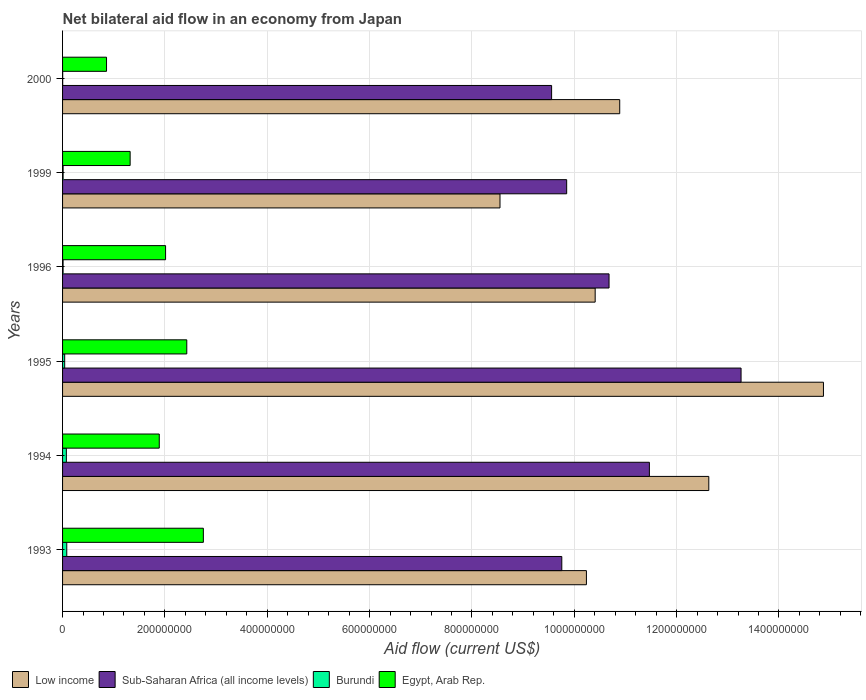How many different coloured bars are there?
Provide a short and direct response. 4. Are the number of bars on each tick of the Y-axis equal?
Your response must be concise. Yes. How many bars are there on the 6th tick from the top?
Offer a very short reply. 4. What is the label of the 6th group of bars from the top?
Provide a succinct answer. 1993. What is the net bilateral aid flow in Egypt, Arab Rep. in 1995?
Provide a succinct answer. 2.43e+08. Across all years, what is the maximum net bilateral aid flow in Burundi?
Your answer should be very brief. 8.21e+06. Across all years, what is the minimum net bilateral aid flow in Low income?
Offer a terse response. 8.55e+08. In which year was the net bilateral aid flow in Sub-Saharan Africa (all income levels) maximum?
Offer a terse response. 1995. What is the total net bilateral aid flow in Egypt, Arab Rep. in the graph?
Make the answer very short. 1.13e+09. What is the difference between the net bilateral aid flow in Burundi in 1994 and that in 2000?
Your answer should be very brief. 7.18e+06. What is the difference between the net bilateral aid flow in Burundi in 1995 and the net bilateral aid flow in Egypt, Arab Rep. in 1999?
Offer a terse response. -1.28e+08. What is the average net bilateral aid flow in Egypt, Arab Rep. per year?
Your answer should be very brief. 1.88e+08. In the year 1996, what is the difference between the net bilateral aid flow in Sub-Saharan Africa (all income levels) and net bilateral aid flow in Low income?
Offer a terse response. 2.71e+07. What is the ratio of the net bilateral aid flow in Egypt, Arab Rep. in 1993 to that in 1999?
Give a very brief answer. 2.08. Is the net bilateral aid flow in Egypt, Arab Rep. in 1994 less than that in 1995?
Offer a terse response. Yes. What is the difference between the highest and the second highest net bilateral aid flow in Burundi?
Keep it short and to the point. 7.90e+05. What is the difference between the highest and the lowest net bilateral aid flow in Sub-Saharan Africa (all income levels)?
Offer a very short reply. 3.70e+08. In how many years, is the net bilateral aid flow in Egypt, Arab Rep. greater than the average net bilateral aid flow in Egypt, Arab Rep. taken over all years?
Give a very brief answer. 4. What does the 3rd bar from the top in 1994 represents?
Your answer should be compact. Sub-Saharan Africa (all income levels). What does the 3rd bar from the bottom in 1993 represents?
Keep it short and to the point. Burundi. How many bars are there?
Your response must be concise. 24. How many years are there in the graph?
Your response must be concise. 6. Does the graph contain any zero values?
Provide a short and direct response. No. Where does the legend appear in the graph?
Give a very brief answer. Bottom left. How many legend labels are there?
Provide a short and direct response. 4. What is the title of the graph?
Give a very brief answer. Net bilateral aid flow in an economy from Japan. Does "Zimbabwe" appear as one of the legend labels in the graph?
Make the answer very short. No. What is the label or title of the Y-axis?
Provide a succinct answer. Years. What is the Aid flow (current US$) in Low income in 1993?
Keep it short and to the point. 1.02e+09. What is the Aid flow (current US$) of Sub-Saharan Africa (all income levels) in 1993?
Keep it short and to the point. 9.76e+08. What is the Aid flow (current US$) in Burundi in 1993?
Offer a very short reply. 8.21e+06. What is the Aid flow (current US$) of Egypt, Arab Rep. in 1993?
Ensure brevity in your answer.  2.75e+08. What is the Aid flow (current US$) of Low income in 1994?
Give a very brief answer. 1.26e+09. What is the Aid flow (current US$) in Sub-Saharan Africa (all income levels) in 1994?
Offer a terse response. 1.15e+09. What is the Aid flow (current US$) of Burundi in 1994?
Your answer should be very brief. 7.42e+06. What is the Aid flow (current US$) in Egypt, Arab Rep. in 1994?
Your response must be concise. 1.89e+08. What is the Aid flow (current US$) in Low income in 1995?
Your response must be concise. 1.49e+09. What is the Aid flow (current US$) in Sub-Saharan Africa (all income levels) in 1995?
Your answer should be compact. 1.33e+09. What is the Aid flow (current US$) of Burundi in 1995?
Provide a succinct answer. 4.14e+06. What is the Aid flow (current US$) in Egypt, Arab Rep. in 1995?
Your answer should be very brief. 2.43e+08. What is the Aid flow (current US$) of Low income in 1996?
Offer a terse response. 1.04e+09. What is the Aid flow (current US$) of Sub-Saharan Africa (all income levels) in 1996?
Give a very brief answer. 1.07e+09. What is the Aid flow (current US$) in Burundi in 1996?
Offer a terse response. 1.01e+06. What is the Aid flow (current US$) in Egypt, Arab Rep. in 1996?
Keep it short and to the point. 2.01e+08. What is the Aid flow (current US$) of Low income in 1999?
Offer a very short reply. 8.55e+08. What is the Aid flow (current US$) in Sub-Saharan Africa (all income levels) in 1999?
Give a very brief answer. 9.85e+08. What is the Aid flow (current US$) of Burundi in 1999?
Your response must be concise. 1.06e+06. What is the Aid flow (current US$) in Egypt, Arab Rep. in 1999?
Your answer should be compact. 1.32e+08. What is the Aid flow (current US$) of Low income in 2000?
Make the answer very short. 1.09e+09. What is the Aid flow (current US$) in Sub-Saharan Africa (all income levels) in 2000?
Offer a terse response. 9.56e+08. What is the Aid flow (current US$) of Egypt, Arab Rep. in 2000?
Make the answer very short. 8.59e+07. Across all years, what is the maximum Aid flow (current US$) of Low income?
Give a very brief answer. 1.49e+09. Across all years, what is the maximum Aid flow (current US$) of Sub-Saharan Africa (all income levels)?
Make the answer very short. 1.33e+09. Across all years, what is the maximum Aid flow (current US$) of Burundi?
Offer a very short reply. 8.21e+06. Across all years, what is the maximum Aid flow (current US$) of Egypt, Arab Rep.?
Keep it short and to the point. 2.75e+08. Across all years, what is the minimum Aid flow (current US$) of Low income?
Your answer should be very brief. 8.55e+08. Across all years, what is the minimum Aid flow (current US$) in Sub-Saharan Africa (all income levels)?
Offer a very short reply. 9.56e+08. Across all years, what is the minimum Aid flow (current US$) in Burundi?
Your answer should be very brief. 2.40e+05. Across all years, what is the minimum Aid flow (current US$) of Egypt, Arab Rep.?
Make the answer very short. 8.59e+07. What is the total Aid flow (current US$) in Low income in the graph?
Your answer should be very brief. 6.76e+09. What is the total Aid flow (current US$) in Sub-Saharan Africa (all income levels) in the graph?
Offer a terse response. 6.46e+09. What is the total Aid flow (current US$) in Burundi in the graph?
Make the answer very short. 2.21e+07. What is the total Aid flow (current US$) of Egypt, Arab Rep. in the graph?
Offer a terse response. 1.13e+09. What is the difference between the Aid flow (current US$) in Low income in 1993 and that in 1994?
Ensure brevity in your answer.  -2.39e+08. What is the difference between the Aid flow (current US$) in Sub-Saharan Africa (all income levels) in 1993 and that in 1994?
Give a very brief answer. -1.71e+08. What is the difference between the Aid flow (current US$) in Burundi in 1993 and that in 1994?
Make the answer very short. 7.90e+05. What is the difference between the Aid flow (current US$) of Egypt, Arab Rep. in 1993 and that in 1994?
Give a very brief answer. 8.62e+07. What is the difference between the Aid flow (current US$) in Low income in 1993 and that in 1995?
Ensure brevity in your answer.  -4.63e+08. What is the difference between the Aid flow (current US$) of Sub-Saharan Africa (all income levels) in 1993 and that in 1995?
Offer a terse response. -3.50e+08. What is the difference between the Aid flow (current US$) in Burundi in 1993 and that in 1995?
Offer a very short reply. 4.07e+06. What is the difference between the Aid flow (current US$) of Egypt, Arab Rep. in 1993 and that in 1995?
Offer a very short reply. 3.24e+07. What is the difference between the Aid flow (current US$) of Low income in 1993 and that in 1996?
Make the answer very short. -1.71e+07. What is the difference between the Aid flow (current US$) in Sub-Saharan Africa (all income levels) in 1993 and that in 1996?
Offer a terse response. -9.23e+07. What is the difference between the Aid flow (current US$) of Burundi in 1993 and that in 1996?
Give a very brief answer. 7.20e+06. What is the difference between the Aid flow (current US$) of Egypt, Arab Rep. in 1993 and that in 1996?
Offer a very short reply. 7.38e+07. What is the difference between the Aid flow (current US$) in Low income in 1993 and that in 1999?
Your response must be concise. 1.69e+08. What is the difference between the Aid flow (current US$) in Sub-Saharan Africa (all income levels) in 1993 and that in 1999?
Your answer should be compact. -9.54e+06. What is the difference between the Aid flow (current US$) in Burundi in 1993 and that in 1999?
Give a very brief answer. 7.15e+06. What is the difference between the Aid flow (current US$) in Egypt, Arab Rep. in 1993 and that in 1999?
Provide a succinct answer. 1.43e+08. What is the difference between the Aid flow (current US$) in Low income in 1993 and that in 2000?
Your response must be concise. -6.51e+07. What is the difference between the Aid flow (current US$) in Sub-Saharan Africa (all income levels) in 1993 and that in 2000?
Your response must be concise. 1.99e+07. What is the difference between the Aid flow (current US$) of Burundi in 1993 and that in 2000?
Your answer should be very brief. 7.97e+06. What is the difference between the Aid flow (current US$) of Egypt, Arab Rep. in 1993 and that in 2000?
Offer a very short reply. 1.89e+08. What is the difference between the Aid flow (current US$) in Low income in 1994 and that in 1995?
Give a very brief answer. -2.24e+08. What is the difference between the Aid flow (current US$) of Sub-Saharan Africa (all income levels) in 1994 and that in 1995?
Your answer should be very brief. -1.79e+08. What is the difference between the Aid flow (current US$) of Burundi in 1994 and that in 1995?
Offer a very short reply. 3.28e+06. What is the difference between the Aid flow (current US$) in Egypt, Arab Rep. in 1994 and that in 1995?
Provide a succinct answer. -5.38e+07. What is the difference between the Aid flow (current US$) in Low income in 1994 and that in 1996?
Give a very brief answer. 2.22e+08. What is the difference between the Aid flow (current US$) of Sub-Saharan Africa (all income levels) in 1994 and that in 1996?
Provide a short and direct response. 7.88e+07. What is the difference between the Aid flow (current US$) of Burundi in 1994 and that in 1996?
Provide a short and direct response. 6.41e+06. What is the difference between the Aid flow (current US$) in Egypt, Arab Rep. in 1994 and that in 1996?
Offer a terse response. -1.23e+07. What is the difference between the Aid flow (current US$) in Low income in 1994 and that in 1999?
Your answer should be very brief. 4.08e+08. What is the difference between the Aid flow (current US$) in Sub-Saharan Africa (all income levels) in 1994 and that in 1999?
Ensure brevity in your answer.  1.62e+08. What is the difference between the Aid flow (current US$) in Burundi in 1994 and that in 1999?
Provide a short and direct response. 6.36e+06. What is the difference between the Aid flow (current US$) of Egypt, Arab Rep. in 1994 and that in 1999?
Provide a short and direct response. 5.69e+07. What is the difference between the Aid flow (current US$) of Low income in 1994 and that in 2000?
Ensure brevity in your answer.  1.74e+08. What is the difference between the Aid flow (current US$) of Sub-Saharan Africa (all income levels) in 1994 and that in 2000?
Ensure brevity in your answer.  1.91e+08. What is the difference between the Aid flow (current US$) in Burundi in 1994 and that in 2000?
Provide a short and direct response. 7.18e+06. What is the difference between the Aid flow (current US$) of Egypt, Arab Rep. in 1994 and that in 2000?
Your answer should be compact. 1.03e+08. What is the difference between the Aid flow (current US$) in Low income in 1995 and that in 1996?
Your response must be concise. 4.46e+08. What is the difference between the Aid flow (current US$) in Sub-Saharan Africa (all income levels) in 1995 and that in 1996?
Offer a very short reply. 2.58e+08. What is the difference between the Aid flow (current US$) in Burundi in 1995 and that in 1996?
Ensure brevity in your answer.  3.13e+06. What is the difference between the Aid flow (current US$) in Egypt, Arab Rep. in 1995 and that in 1996?
Ensure brevity in your answer.  4.14e+07. What is the difference between the Aid flow (current US$) of Low income in 1995 and that in 1999?
Your response must be concise. 6.32e+08. What is the difference between the Aid flow (current US$) of Sub-Saharan Africa (all income levels) in 1995 and that in 1999?
Offer a very short reply. 3.41e+08. What is the difference between the Aid flow (current US$) in Burundi in 1995 and that in 1999?
Ensure brevity in your answer.  3.08e+06. What is the difference between the Aid flow (current US$) of Egypt, Arab Rep. in 1995 and that in 1999?
Provide a succinct answer. 1.11e+08. What is the difference between the Aid flow (current US$) of Low income in 1995 and that in 2000?
Give a very brief answer. 3.98e+08. What is the difference between the Aid flow (current US$) in Sub-Saharan Africa (all income levels) in 1995 and that in 2000?
Make the answer very short. 3.70e+08. What is the difference between the Aid flow (current US$) in Burundi in 1995 and that in 2000?
Your answer should be compact. 3.90e+06. What is the difference between the Aid flow (current US$) of Egypt, Arab Rep. in 1995 and that in 2000?
Ensure brevity in your answer.  1.57e+08. What is the difference between the Aid flow (current US$) of Low income in 1996 and that in 1999?
Make the answer very short. 1.86e+08. What is the difference between the Aid flow (current US$) in Sub-Saharan Africa (all income levels) in 1996 and that in 1999?
Ensure brevity in your answer.  8.28e+07. What is the difference between the Aid flow (current US$) in Egypt, Arab Rep. in 1996 and that in 1999?
Offer a very short reply. 6.92e+07. What is the difference between the Aid flow (current US$) of Low income in 1996 and that in 2000?
Keep it short and to the point. -4.80e+07. What is the difference between the Aid flow (current US$) of Sub-Saharan Africa (all income levels) in 1996 and that in 2000?
Give a very brief answer. 1.12e+08. What is the difference between the Aid flow (current US$) in Burundi in 1996 and that in 2000?
Keep it short and to the point. 7.70e+05. What is the difference between the Aid flow (current US$) of Egypt, Arab Rep. in 1996 and that in 2000?
Your answer should be very brief. 1.15e+08. What is the difference between the Aid flow (current US$) in Low income in 1999 and that in 2000?
Make the answer very short. -2.34e+08. What is the difference between the Aid flow (current US$) in Sub-Saharan Africa (all income levels) in 1999 and that in 2000?
Your answer should be very brief. 2.94e+07. What is the difference between the Aid flow (current US$) in Burundi in 1999 and that in 2000?
Keep it short and to the point. 8.20e+05. What is the difference between the Aid flow (current US$) of Egypt, Arab Rep. in 1999 and that in 2000?
Make the answer very short. 4.62e+07. What is the difference between the Aid flow (current US$) of Low income in 1993 and the Aid flow (current US$) of Sub-Saharan Africa (all income levels) in 1994?
Make the answer very short. -1.23e+08. What is the difference between the Aid flow (current US$) in Low income in 1993 and the Aid flow (current US$) in Burundi in 1994?
Keep it short and to the point. 1.02e+09. What is the difference between the Aid flow (current US$) of Low income in 1993 and the Aid flow (current US$) of Egypt, Arab Rep. in 1994?
Your answer should be very brief. 8.35e+08. What is the difference between the Aid flow (current US$) of Sub-Saharan Africa (all income levels) in 1993 and the Aid flow (current US$) of Burundi in 1994?
Provide a succinct answer. 9.68e+08. What is the difference between the Aid flow (current US$) in Sub-Saharan Africa (all income levels) in 1993 and the Aid flow (current US$) in Egypt, Arab Rep. in 1994?
Your response must be concise. 7.87e+08. What is the difference between the Aid flow (current US$) in Burundi in 1993 and the Aid flow (current US$) in Egypt, Arab Rep. in 1994?
Make the answer very short. -1.81e+08. What is the difference between the Aid flow (current US$) in Low income in 1993 and the Aid flow (current US$) in Sub-Saharan Africa (all income levels) in 1995?
Ensure brevity in your answer.  -3.02e+08. What is the difference between the Aid flow (current US$) of Low income in 1993 and the Aid flow (current US$) of Burundi in 1995?
Make the answer very short. 1.02e+09. What is the difference between the Aid flow (current US$) in Low income in 1993 and the Aid flow (current US$) in Egypt, Arab Rep. in 1995?
Make the answer very short. 7.81e+08. What is the difference between the Aid flow (current US$) in Sub-Saharan Africa (all income levels) in 1993 and the Aid flow (current US$) in Burundi in 1995?
Offer a terse response. 9.71e+08. What is the difference between the Aid flow (current US$) in Sub-Saharan Africa (all income levels) in 1993 and the Aid flow (current US$) in Egypt, Arab Rep. in 1995?
Give a very brief answer. 7.33e+08. What is the difference between the Aid flow (current US$) in Burundi in 1993 and the Aid flow (current US$) in Egypt, Arab Rep. in 1995?
Offer a terse response. -2.35e+08. What is the difference between the Aid flow (current US$) of Low income in 1993 and the Aid flow (current US$) of Sub-Saharan Africa (all income levels) in 1996?
Make the answer very short. -4.42e+07. What is the difference between the Aid flow (current US$) in Low income in 1993 and the Aid flow (current US$) in Burundi in 1996?
Offer a very short reply. 1.02e+09. What is the difference between the Aid flow (current US$) in Low income in 1993 and the Aid flow (current US$) in Egypt, Arab Rep. in 1996?
Offer a very short reply. 8.22e+08. What is the difference between the Aid flow (current US$) in Sub-Saharan Africa (all income levels) in 1993 and the Aid flow (current US$) in Burundi in 1996?
Offer a terse response. 9.75e+08. What is the difference between the Aid flow (current US$) of Sub-Saharan Africa (all income levels) in 1993 and the Aid flow (current US$) of Egypt, Arab Rep. in 1996?
Ensure brevity in your answer.  7.74e+08. What is the difference between the Aid flow (current US$) of Burundi in 1993 and the Aid flow (current US$) of Egypt, Arab Rep. in 1996?
Keep it short and to the point. -1.93e+08. What is the difference between the Aid flow (current US$) of Low income in 1993 and the Aid flow (current US$) of Sub-Saharan Africa (all income levels) in 1999?
Provide a short and direct response. 3.86e+07. What is the difference between the Aid flow (current US$) of Low income in 1993 and the Aid flow (current US$) of Burundi in 1999?
Your answer should be compact. 1.02e+09. What is the difference between the Aid flow (current US$) of Low income in 1993 and the Aid flow (current US$) of Egypt, Arab Rep. in 1999?
Provide a succinct answer. 8.92e+08. What is the difference between the Aid flow (current US$) of Sub-Saharan Africa (all income levels) in 1993 and the Aid flow (current US$) of Burundi in 1999?
Your answer should be compact. 9.75e+08. What is the difference between the Aid flow (current US$) of Sub-Saharan Africa (all income levels) in 1993 and the Aid flow (current US$) of Egypt, Arab Rep. in 1999?
Ensure brevity in your answer.  8.44e+08. What is the difference between the Aid flow (current US$) in Burundi in 1993 and the Aid flow (current US$) in Egypt, Arab Rep. in 1999?
Your response must be concise. -1.24e+08. What is the difference between the Aid flow (current US$) in Low income in 1993 and the Aid flow (current US$) in Sub-Saharan Africa (all income levels) in 2000?
Provide a short and direct response. 6.80e+07. What is the difference between the Aid flow (current US$) of Low income in 1993 and the Aid flow (current US$) of Burundi in 2000?
Offer a very short reply. 1.02e+09. What is the difference between the Aid flow (current US$) of Low income in 1993 and the Aid flow (current US$) of Egypt, Arab Rep. in 2000?
Provide a short and direct response. 9.38e+08. What is the difference between the Aid flow (current US$) in Sub-Saharan Africa (all income levels) in 1993 and the Aid flow (current US$) in Burundi in 2000?
Your response must be concise. 9.75e+08. What is the difference between the Aid flow (current US$) of Sub-Saharan Africa (all income levels) in 1993 and the Aid flow (current US$) of Egypt, Arab Rep. in 2000?
Make the answer very short. 8.90e+08. What is the difference between the Aid flow (current US$) of Burundi in 1993 and the Aid flow (current US$) of Egypt, Arab Rep. in 2000?
Ensure brevity in your answer.  -7.77e+07. What is the difference between the Aid flow (current US$) of Low income in 1994 and the Aid flow (current US$) of Sub-Saharan Africa (all income levels) in 1995?
Offer a terse response. -6.30e+07. What is the difference between the Aid flow (current US$) in Low income in 1994 and the Aid flow (current US$) in Burundi in 1995?
Your answer should be compact. 1.26e+09. What is the difference between the Aid flow (current US$) in Low income in 1994 and the Aid flow (current US$) in Egypt, Arab Rep. in 1995?
Make the answer very short. 1.02e+09. What is the difference between the Aid flow (current US$) in Sub-Saharan Africa (all income levels) in 1994 and the Aid flow (current US$) in Burundi in 1995?
Ensure brevity in your answer.  1.14e+09. What is the difference between the Aid flow (current US$) in Sub-Saharan Africa (all income levels) in 1994 and the Aid flow (current US$) in Egypt, Arab Rep. in 1995?
Your answer should be compact. 9.04e+08. What is the difference between the Aid flow (current US$) of Burundi in 1994 and the Aid flow (current US$) of Egypt, Arab Rep. in 1995?
Keep it short and to the point. -2.35e+08. What is the difference between the Aid flow (current US$) of Low income in 1994 and the Aid flow (current US$) of Sub-Saharan Africa (all income levels) in 1996?
Offer a terse response. 1.95e+08. What is the difference between the Aid flow (current US$) of Low income in 1994 and the Aid flow (current US$) of Burundi in 1996?
Ensure brevity in your answer.  1.26e+09. What is the difference between the Aid flow (current US$) in Low income in 1994 and the Aid flow (current US$) in Egypt, Arab Rep. in 1996?
Offer a very short reply. 1.06e+09. What is the difference between the Aid flow (current US$) of Sub-Saharan Africa (all income levels) in 1994 and the Aid flow (current US$) of Burundi in 1996?
Your answer should be compact. 1.15e+09. What is the difference between the Aid flow (current US$) in Sub-Saharan Africa (all income levels) in 1994 and the Aid flow (current US$) in Egypt, Arab Rep. in 1996?
Make the answer very short. 9.45e+08. What is the difference between the Aid flow (current US$) of Burundi in 1994 and the Aid flow (current US$) of Egypt, Arab Rep. in 1996?
Provide a short and direct response. -1.94e+08. What is the difference between the Aid flow (current US$) of Low income in 1994 and the Aid flow (current US$) of Sub-Saharan Africa (all income levels) in 1999?
Offer a terse response. 2.78e+08. What is the difference between the Aid flow (current US$) of Low income in 1994 and the Aid flow (current US$) of Burundi in 1999?
Provide a succinct answer. 1.26e+09. What is the difference between the Aid flow (current US$) in Low income in 1994 and the Aid flow (current US$) in Egypt, Arab Rep. in 1999?
Your answer should be very brief. 1.13e+09. What is the difference between the Aid flow (current US$) in Sub-Saharan Africa (all income levels) in 1994 and the Aid flow (current US$) in Burundi in 1999?
Your answer should be very brief. 1.15e+09. What is the difference between the Aid flow (current US$) of Sub-Saharan Africa (all income levels) in 1994 and the Aid flow (current US$) of Egypt, Arab Rep. in 1999?
Keep it short and to the point. 1.01e+09. What is the difference between the Aid flow (current US$) in Burundi in 1994 and the Aid flow (current US$) in Egypt, Arab Rep. in 1999?
Make the answer very short. -1.25e+08. What is the difference between the Aid flow (current US$) in Low income in 1994 and the Aid flow (current US$) in Sub-Saharan Africa (all income levels) in 2000?
Provide a short and direct response. 3.07e+08. What is the difference between the Aid flow (current US$) in Low income in 1994 and the Aid flow (current US$) in Burundi in 2000?
Your response must be concise. 1.26e+09. What is the difference between the Aid flow (current US$) of Low income in 1994 and the Aid flow (current US$) of Egypt, Arab Rep. in 2000?
Your response must be concise. 1.18e+09. What is the difference between the Aid flow (current US$) in Sub-Saharan Africa (all income levels) in 1994 and the Aid flow (current US$) in Burundi in 2000?
Provide a short and direct response. 1.15e+09. What is the difference between the Aid flow (current US$) of Sub-Saharan Africa (all income levels) in 1994 and the Aid flow (current US$) of Egypt, Arab Rep. in 2000?
Your answer should be very brief. 1.06e+09. What is the difference between the Aid flow (current US$) in Burundi in 1994 and the Aid flow (current US$) in Egypt, Arab Rep. in 2000?
Keep it short and to the point. -7.85e+07. What is the difference between the Aid flow (current US$) in Low income in 1995 and the Aid flow (current US$) in Sub-Saharan Africa (all income levels) in 1996?
Provide a succinct answer. 4.19e+08. What is the difference between the Aid flow (current US$) in Low income in 1995 and the Aid flow (current US$) in Burundi in 1996?
Keep it short and to the point. 1.49e+09. What is the difference between the Aid flow (current US$) of Low income in 1995 and the Aid flow (current US$) of Egypt, Arab Rep. in 1996?
Your response must be concise. 1.29e+09. What is the difference between the Aid flow (current US$) of Sub-Saharan Africa (all income levels) in 1995 and the Aid flow (current US$) of Burundi in 1996?
Ensure brevity in your answer.  1.32e+09. What is the difference between the Aid flow (current US$) in Sub-Saharan Africa (all income levels) in 1995 and the Aid flow (current US$) in Egypt, Arab Rep. in 1996?
Provide a short and direct response. 1.12e+09. What is the difference between the Aid flow (current US$) in Burundi in 1995 and the Aid flow (current US$) in Egypt, Arab Rep. in 1996?
Offer a terse response. -1.97e+08. What is the difference between the Aid flow (current US$) of Low income in 1995 and the Aid flow (current US$) of Sub-Saharan Africa (all income levels) in 1999?
Your answer should be very brief. 5.02e+08. What is the difference between the Aid flow (current US$) in Low income in 1995 and the Aid flow (current US$) in Burundi in 1999?
Offer a very short reply. 1.49e+09. What is the difference between the Aid flow (current US$) of Low income in 1995 and the Aid flow (current US$) of Egypt, Arab Rep. in 1999?
Provide a short and direct response. 1.35e+09. What is the difference between the Aid flow (current US$) in Sub-Saharan Africa (all income levels) in 1995 and the Aid flow (current US$) in Burundi in 1999?
Provide a short and direct response. 1.32e+09. What is the difference between the Aid flow (current US$) in Sub-Saharan Africa (all income levels) in 1995 and the Aid flow (current US$) in Egypt, Arab Rep. in 1999?
Make the answer very short. 1.19e+09. What is the difference between the Aid flow (current US$) of Burundi in 1995 and the Aid flow (current US$) of Egypt, Arab Rep. in 1999?
Ensure brevity in your answer.  -1.28e+08. What is the difference between the Aid flow (current US$) in Low income in 1995 and the Aid flow (current US$) in Sub-Saharan Africa (all income levels) in 2000?
Provide a short and direct response. 5.31e+08. What is the difference between the Aid flow (current US$) in Low income in 1995 and the Aid flow (current US$) in Burundi in 2000?
Your answer should be very brief. 1.49e+09. What is the difference between the Aid flow (current US$) of Low income in 1995 and the Aid flow (current US$) of Egypt, Arab Rep. in 2000?
Provide a short and direct response. 1.40e+09. What is the difference between the Aid flow (current US$) of Sub-Saharan Africa (all income levels) in 1995 and the Aid flow (current US$) of Burundi in 2000?
Offer a very short reply. 1.33e+09. What is the difference between the Aid flow (current US$) in Sub-Saharan Africa (all income levels) in 1995 and the Aid flow (current US$) in Egypt, Arab Rep. in 2000?
Keep it short and to the point. 1.24e+09. What is the difference between the Aid flow (current US$) of Burundi in 1995 and the Aid flow (current US$) of Egypt, Arab Rep. in 2000?
Make the answer very short. -8.18e+07. What is the difference between the Aid flow (current US$) of Low income in 1996 and the Aid flow (current US$) of Sub-Saharan Africa (all income levels) in 1999?
Offer a very short reply. 5.57e+07. What is the difference between the Aid flow (current US$) of Low income in 1996 and the Aid flow (current US$) of Burundi in 1999?
Provide a short and direct response. 1.04e+09. What is the difference between the Aid flow (current US$) of Low income in 1996 and the Aid flow (current US$) of Egypt, Arab Rep. in 1999?
Provide a short and direct response. 9.09e+08. What is the difference between the Aid flow (current US$) of Sub-Saharan Africa (all income levels) in 1996 and the Aid flow (current US$) of Burundi in 1999?
Offer a very short reply. 1.07e+09. What is the difference between the Aid flow (current US$) of Sub-Saharan Africa (all income levels) in 1996 and the Aid flow (current US$) of Egypt, Arab Rep. in 1999?
Your answer should be very brief. 9.36e+08. What is the difference between the Aid flow (current US$) of Burundi in 1996 and the Aid flow (current US$) of Egypt, Arab Rep. in 1999?
Offer a very short reply. -1.31e+08. What is the difference between the Aid flow (current US$) of Low income in 1996 and the Aid flow (current US$) of Sub-Saharan Africa (all income levels) in 2000?
Ensure brevity in your answer.  8.51e+07. What is the difference between the Aid flow (current US$) of Low income in 1996 and the Aid flow (current US$) of Burundi in 2000?
Keep it short and to the point. 1.04e+09. What is the difference between the Aid flow (current US$) of Low income in 1996 and the Aid flow (current US$) of Egypt, Arab Rep. in 2000?
Make the answer very short. 9.55e+08. What is the difference between the Aid flow (current US$) of Sub-Saharan Africa (all income levels) in 1996 and the Aid flow (current US$) of Burundi in 2000?
Provide a short and direct response. 1.07e+09. What is the difference between the Aid flow (current US$) in Sub-Saharan Africa (all income levels) in 1996 and the Aid flow (current US$) in Egypt, Arab Rep. in 2000?
Provide a succinct answer. 9.82e+08. What is the difference between the Aid flow (current US$) in Burundi in 1996 and the Aid flow (current US$) in Egypt, Arab Rep. in 2000?
Give a very brief answer. -8.49e+07. What is the difference between the Aid flow (current US$) of Low income in 1999 and the Aid flow (current US$) of Sub-Saharan Africa (all income levels) in 2000?
Offer a very short reply. -1.01e+08. What is the difference between the Aid flow (current US$) in Low income in 1999 and the Aid flow (current US$) in Burundi in 2000?
Offer a very short reply. 8.55e+08. What is the difference between the Aid flow (current US$) in Low income in 1999 and the Aid flow (current US$) in Egypt, Arab Rep. in 2000?
Provide a short and direct response. 7.69e+08. What is the difference between the Aid flow (current US$) of Sub-Saharan Africa (all income levels) in 1999 and the Aid flow (current US$) of Burundi in 2000?
Your response must be concise. 9.85e+08. What is the difference between the Aid flow (current US$) of Sub-Saharan Africa (all income levels) in 1999 and the Aid flow (current US$) of Egypt, Arab Rep. in 2000?
Your answer should be compact. 8.99e+08. What is the difference between the Aid flow (current US$) in Burundi in 1999 and the Aid flow (current US$) in Egypt, Arab Rep. in 2000?
Your response must be concise. -8.49e+07. What is the average Aid flow (current US$) of Low income per year?
Ensure brevity in your answer.  1.13e+09. What is the average Aid flow (current US$) in Sub-Saharan Africa (all income levels) per year?
Offer a very short reply. 1.08e+09. What is the average Aid flow (current US$) of Burundi per year?
Your answer should be very brief. 3.68e+06. What is the average Aid flow (current US$) of Egypt, Arab Rep. per year?
Offer a terse response. 1.88e+08. In the year 1993, what is the difference between the Aid flow (current US$) in Low income and Aid flow (current US$) in Sub-Saharan Africa (all income levels)?
Give a very brief answer. 4.81e+07. In the year 1993, what is the difference between the Aid flow (current US$) of Low income and Aid flow (current US$) of Burundi?
Give a very brief answer. 1.02e+09. In the year 1993, what is the difference between the Aid flow (current US$) of Low income and Aid flow (current US$) of Egypt, Arab Rep.?
Provide a short and direct response. 7.49e+08. In the year 1993, what is the difference between the Aid flow (current US$) of Sub-Saharan Africa (all income levels) and Aid flow (current US$) of Burundi?
Offer a terse response. 9.67e+08. In the year 1993, what is the difference between the Aid flow (current US$) of Sub-Saharan Africa (all income levels) and Aid flow (current US$) of Egypt, Arab Rep.?
Keep it short and to the point. 7.00e+08. In the year 1993, what is the difference between the Aid flow (current US$) of Burundi and Aid flow (current US$) of Egypt, Arab Rep.?
Give a very brief answer. -2.67e+08. In the year 1994, what is the difference between the Aid flow (current US$) in Low income and Aid flow (current US$) in Sub-Saharan Africa (all income levels)?
Provide a succinct answer. 1.16e+08. In the year 1994, what is the difference between the Aid flow (current US$) of Low income and Aid flow (current US$) of Burundi?
Make the answer very short. 1.26e+09. In the year 1994, what is the difference between the Aid flow (current US$) of Low income and Aid flow (current US$) of Egypt, Arab Rep.?
Ensure brevity in your answer.  1.07e+09. In the year 1994, what is the difference between the Aid flow (current US$) in Sub-Saharan Africa (all income levels) and Aid flow (current US$) in Burundi?
Give a very brief answer. 1.14e+09. In the year 1994, what is the difference between the Aid flow (current US$) of Sub-Saharan Africa (all income levels) and Aid flow (current US$) of Egypt, Arab Rep.?
Make the answer very short. 9.58e+08. In the year 1994, what is the difference between the Aid flow (current US$) in Burundi and Aid flow (current US$) in Egypt, Arab Rep.?
Make the answer very short. -1.82e+08. In the year 1995, what is the difference between the Aid flow (current US$) in Low income and Aid flow (current US$) in Sub-Saharan Africa (all income levels)?
Provide a short and direct response. 1.61e+08. In the year 1995, what is the difference between the Aid flow (current US$) of Low income and Aid flow (current US$) of Burundi?
Provide a succinct answer. 1.48e+09. In the year 1995, what is the difference between the Aid flow (current US$) of Low income and Aid flow (current US$) of Egypt, Arab Rep.?
Your answer should be very brief. 1.24e+09. In the year 1995, what is the difference between the Aid flow (current US$) of Sub-Saharan Africa (all income levels) and Aid flow (current US$) of Burundi?
Give a very brief answer. 1.32e+09. In the year 1995, what is the difference between the Aid flow (current US$) in Sub-Saharan Africa (all income levels) and Aid flow (current US$) in Egypt, Arab Rep.?
Ensure brevity in your answer.  1.08e+09. In the year 1995, what is the difference between the Aid flow (current US$) in Burundi and Aid flow (current US$) in Egypt, Arab Rep.?
Provide a succinct answer. -2.39e+08. In the year 1996, what is the difference between the Aid flow (current US$) in Low income and Aid flow (current US$) in Sub-Saharan Africa (all income levels)?
Provide a succinct answer. -2.71e+07. In the year 1996, what is the difference between the Aid flow (current US$) of Low income and Aid flow (current US$) of Burundi?
Your answer should be very brief. 1.04e+09. In the year 1996, what is the difference between the Aid flow (current US$) in Low income and Aid flow (current US$) in Egypt, Arab Rep.?
Your answer should be very brief. 8.40e+08. In the year 1996, what is the difference between the Aid flow (current US$) of Sub-Saharan Africa (all income levels) and Aid flow (current US$) of Burundi?
Keep it short and to the point. 1.07e+09. In the year 1996, what is the difference between the Aid flow (current US$) of Sub-Saharan Africa (all income levels) and Aid flow (current US$) of Egypt, Arab Rep.?
Offer a very short reply. 8.67e+08. In the year 1996, what is the difference between the Aid flow (current US$) of Burundi and Aid flow (current US$) of Egypt, Arab Rep.?
Offer a very short reply. -2.00e+08. In the year 1999, what is the difference between the Aid flow (current US$) in Low income and Aid flow (current US$) in Sub-Saharan Africa (all income levels)?
Provide a short and direct response. -1.30e+08. In the year 1999, what is the difference between the Aid flow (current US$) in Low income and Aid flow (current US$) in Burundi?
Provide a succinct answer. 8.54e+08. In the year 1999, what is the difference between the Aid flow (current US$) of Low income and Aid flow (current US$) of Egypt, Arab Rep.?
Provide a succinct answer. 7.23e+08. In the year 1999, what is the difference between the Aid flow (current US$) of Sub-Saharan Africa (all income levels) and Aid flow (current US$) of Burundi?
Provide a short and direct response. 9.84e+08. In the year 1999, what is the difference between the Aid flow (current US$) of Sub-Saharan Africa (all income levels) and Aid flow (current US$) of Egypt, Arab Rep.?
Make the answer very short. 8.53e+08. In the year 1999, what is the difference between the Aid flow (current US$) in Burundi and Aid flow (current US$) in Egypt, Arab Rep.?
Your answer should be very brief. -1.31e+08. In the year 2000, what is the difference between the Aid flow (current US$) of Low income and Aid flow (current US$) of Sub-Saharan Africa (all income levels)?
Provide a short and direct response. 1.33e+08. In the year 2000, what is the difference between the Aid flow (current US$) of Low income and Aid flow (current US$) of Burundi?
Your answer should be compact. 1.09e+09. In the year 2000, what is the difference between the Aid flow (current US$) of Low income and Aid flow (current US$) of Egypt, Arab Rep.?
Provide a succinct answer. 1.00e+09. In the year 2000, what is the difference between the Aid flow (current US$) in Sub-Saharan Africa (all income levels) and Aid flow (current US$) in Burundi?
Give a very brief answer. 9.55e+08. In the year 2000, what is the difference between the Aid flow (current US$) of Sub-Saharan Africa (all income levels) and Aid flow (current US$) of Egypt, Arab Rep.?
Your response must be concise. 8.70e+08. In the year 2000, what is the difference between the Aid flow (current US$) in Burundi and Aid flow (current US$) in Egypt, Arab Rep.?
Your answer should be very brief. -8.57e+07. What is the ratio of the Aid flow (current US$) in Low income in 1993 to that in 1994?
Your answer should be very brief. 0.81. What is the ratio of the Aid flow (current US$) of Sub-Saharan Africa (all income levels) in 1993 to that in 1994?
Your answer should be compact. 0.85. What is the ratio of the Aid flow (current US$) in Burundi in 1993 to that in 1994?
Ensure brevity in your answer.  1.11. What is the ratio of the Aid flow (current US$) in Egypt, Arab Rep. in 1993 to that in 1994?
Keep it short and to the point. 1.46. What is the ratio of the Aid flow (current US$) of Low income in 1993 to that in 1995?
Provide a succinct answer. 0.69. What is the ratio of the Aid flow (current US$) of Sub-Saharan Africa (all income levels) in 1993 to that in 1995?
Provide a short and direct response. 0.74. What is the ratio of the Aid flow (current US$) in Burundi in 1993 to that in 1995?
Your response must be concise. 1.98. What is the ratio of the Aid flow (current US$) of Egypt, Arab Rep. in 1993 to that in 1995?
Provide a succinct answer. 1.13. What is the ratio of the Aid flow (current US$) in Low income in 1993 to that in 1996?
Your answer should be compact. 0.98. What is the ratio of the Aid flow (current US$) of Sub-Saharan Africa (all income levels) in 1993 to that in 1996?
Provide a succinct answer. 0.91. What is the ratio of the Aid flow (current US$) in Burundi in 1993 to that in 1996?
Offer a very short reply. 8.13. What is the ratio of the Aid flow (current US$) of Egypt, Arab Rep. in 1993 to that in 1996?
Provide a short and direct response. 1.37. What is the ratio of the Aid flow (current US$) of Low income in 1993 to that in 1999?
Offer a terse response. 1.2. What is the ratio of the Aid flow (current US$) of Sub-Saharan Africa (all income levels) in 1993 to that in 1999?
Your answer should be compact. 0.99. What is the ratio of the Aid flow (current US$) of Burundi in 1993 to that in 1999?
Offer a very short reply. 7.75. What is the ratio of the Aid flow (current US$) in Egypt, Arab Rep. in 1993 to that in 1999?
Make the answer very short. 2.08. What is the ratio of the Aid flow (current US$) in Low income in 1993 to that in 2000?
Offer a very short reply. 0.94. What is the ratio of the Aid flow (current US$) of Sub-Saharan Africa (all income levels) in 1993 to that in 2000?
Ensure brevity in your answer.  1.02. What is the ratio of the Aid flow (current US$) in Burundi in 1993 to that in 2000?
Offer a terse response. 34.21. What is the ratio of the Aid flow (current US$) of Egypt, Arab Rep. in 1993 to that in 2000?
Keep it short and to the point. 3.2. What is the ratio of the Aid flow (current US$) of Low income in 1994 to that in 1995?
Keep it short and to the point. 0.85. What is the ratio of the Aid flow (current US$) of Sub-Saharan Africa (all income levels) in 1994 to that in 1995?
Your answer should be compact. 0.86. What is the ratio of the Aid flow (current US$) in Burundi in 1994 to that in 1995?
Offer a very short reply. 1.79. What is the ratio of the Aid flow (current US$) in Egypt, Arab Rep. in 1994 to that in 1995?
Give a very brief answer. 0.78. What is the ratio of the Aid flow (current US$) in Low income in 1994 to that in 1996?
Keep it short and to the point. 1.21. What is the ratio of the Aid flow (current US$) of Sub-Saharan Africa (all income levels) in 1994 to that in 1996?
Your answer should be compact. 1.07. What is the ratio of the Aid flow (current US$) of Burundi in 1994 to that in 1996?
Keep it short and to the point. 7.35. What is the ratio of the Aid flow (current US$) in Egypt, Arab Rep. in 1994 to that in 1996?
Ensure brevity in your answer.  0.94. What is the ratio of the Aid flow (current US$) in Low income in 1994 to that in 1999?
Provide a succinct answer. 1.48. What is the ratio of the Aid flow (current US$) in Sub-Saharan Africa (all income levels) in 1994 to that in 1999?
Offer a very short reply. 1.16. What is the ratio of the Aid flow (current US$) in Egypt, Arab Rep. in 1994 to that in 1999?
Offer a terse response. 1.43. What is the ratio of the Aid flow (current US$) of Low income in 1994 to that in 2000?
Provide a short and direct response. 1.16. What is the ratio of the Aid flow (current US$) of Sub-Saharan Africa (all income levels) in 1994 to that in 2000?
Give a very brief answer. 1.2. What is the ratio of the Aid flow (current US$) of Burundi in 1994 to that in 2000?
Make the answer very short. 30.92. What is the ratio of the Aid flow (current US$) of Egypt, Arab Rep. in 1994 to that in 2000?
Your answer should be compact. 2.2. What is the ratio of the Aid flow (current US$) of Low income in 1995 to that in 1996?
Offer a very short reply. 1.43. What is the ratio of the Aid flow (current US$) in Sub-Saharan Africa (all income levels) in 1995 to that in 1996?
Make the answer very short. 1.24. What is the ratio of the Aid flow (current US$) in Burundi in 1995 to that in 1996?
Your response must be concise. 4.1. What is the ratio of the Aid flow (current US$) of Egypt, Arab Rep. in 1995 to that in 1996?
Make the answer very short. 1.21. What is the ratio of the Aid flow (current US$) of Low income in 1995 to that in 1999?
Ensure brevity in your answer.  1.74. What is the ratio of the Aid flow (current US$) of Sub-Saharan Africa (all income levels) in 1995 to that in 1999?
Provide a succinct answer. 1.35. What is the ratio of the Aid flow (current US$) of Burundi in 1995 to that in 1999?
Your response must be concise. 3.91. What is the ratio of the Aid flow (current US$) in Egypt, Arab Rep. in 1995 to that in 1999?
Provide a succinct answer. 1.84. What is the ratio of the Aid flow (current US$) of Low income in 1995 to that in 2000?
Keep it short and to the point. 1.37. What is the ratio of the Aid flow (current US$) in Sub-Saharan Africa (all income levels) in 1995 to that in 2000?
Ensure brevity in your answer.  1.39. What is the ratio of the Aid flow (current US$) in Burundi in 1995 to that in 2000?
Your response must be concise. 17.25. What is the ratio of the Aid flow (current US$) in Egypt, Arab Rep. in 1995 to that in 2000?
Provide a short and direct response. 2.83. What is the ratio of the Aid flow (current US$) of Low income in 1996 to that in 1999?
Provide a short and direct response. 1.22. What is the ratio of the Aid flow (current US$) of Sub-Saharan Africa (all income levels) in 1996 to that in 1999?
Your answer should be compact. 1.08. What is the ratio of the Aid flow (current US$) in Burundi in 1996 to that in 1999?
Offer a very short reply. 0.95. What is the ratio of the Aid flow (current US$) in Egypt, Arab Rep. in 1996 to that in 1999?
Make the answer very short. 1.52. What is the ratio of the Aid flow (current US$) in Low income in 1996 to that in 2000?
Provide a short and direct response. 0.96. What is the ratio of the Aid flow (current US$) in Sub-Saharan Africa (all income levels) in 1996 to that in 2000?
Make the answer very short. 1.12. What is the ratio of the Aid flow (current US$) of Burundi in 1996 to that in 2000?
Your answer should be compact. 4.21. What is the ratio of the Aid flow (current US$) in Egypt, Arab Rep. in 1996 to that in 2000?
Your answer should be compact. 2.34. What is the ratio of the Aid flow (current US$) in Low income in 1999 to that in 2000?
Offer a terse response. 0.79. What is the ratio of the Aid flow (current US$) in Sub-Saharan Africa (all income levels) in 1999 to that in 2000?
Make the answer very short. 1.03. What is the ratio of the Aid flow (current US$) of Burundi in 1999 to that in 2000?
Offer a very short reply. 4.42. What is the ratio of the Aid flow (current US$) in Egypt, Arab Rep. in 1999 to that in 2000?
Offer a terse response. 1.54. What is the difference between the highest and the second highest Aid flow (current US$) in Low income?
Ensure brevity in your answer.  2.24e+08. What is the difference between the highest and the second highest Aid flow (current US$) in Sub-Saharan Africa (all income levels)?
Keep it short and to the point. 1.79e+08. What is the difference between the highest and the second highest Aid flow (current US$) of Burundi?
Make the answer very short. 7.90e+05. What is the difference between the highest and the second highest Aid flow (current US$) of Egypt, Arab Rep.?
Provide a short and direct response. 3.24e+07. What is the difference between the highest and the lowest Aid flow (current US$) of Low income?
Your response must be concise. 6.32e+08. What is the difference between the highest and the lowest Aid flow (current US$) of Sub-Saharan Africa (all income levels)?
Your response must be concise. 3.70e+08. What is the difference between the highest and the lowest Aid flow (current US$) in Burundi?
Your answer should be very brief. 7.97e+06. What is the difference between the highest and the lowest Aid flow (current US$) in Egypt, Arab Rep.?
Your answer should be compact. 1.89e+08. 